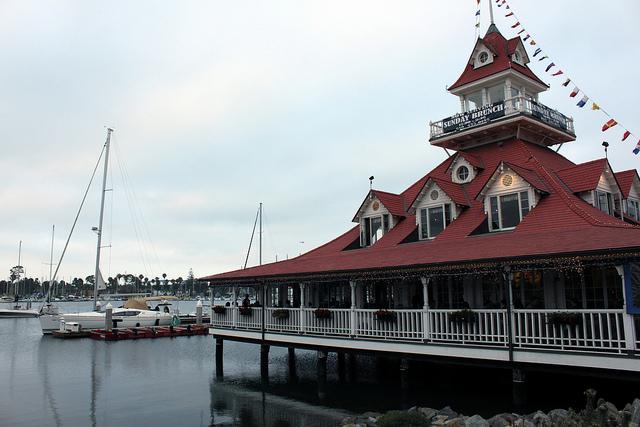What is the building?
Answer briefly. Restaurant. What type of building is in the water?
Keep it brief. Restaurant. Is this photo from this century?
Quick response, please. Yes. Is there a widow's walk on the building?
Keep it brief. Yes. Are there Gables?
Short answer required. Yes. 